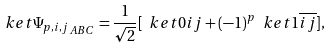Convert formula to latex. <formula><loc_0><loc_0><loc_500><loc_500>\ k e t { \Psi _ { p , i , j } } _ { A B C } = \frac { 1 } { \sqrt { 2 } } [ \ k e t { 0 i j } + ( - 1 ) ^ { p } \ k e t { 1 \overline { i } \overline { j } } ] ,</formula> 